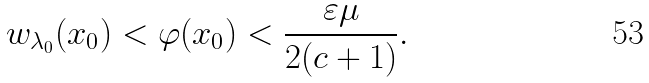Convert formula to latex. <formula><loc_0><loc_0><loc_500><loc_500>w _ { \lambda _ { 0 } } ( x _ { 0 } ) < \varphi ( x _ { 0 } ) < \frac { \varepsilon \mu } { 2 ( c + 1 ) } .</formula> 